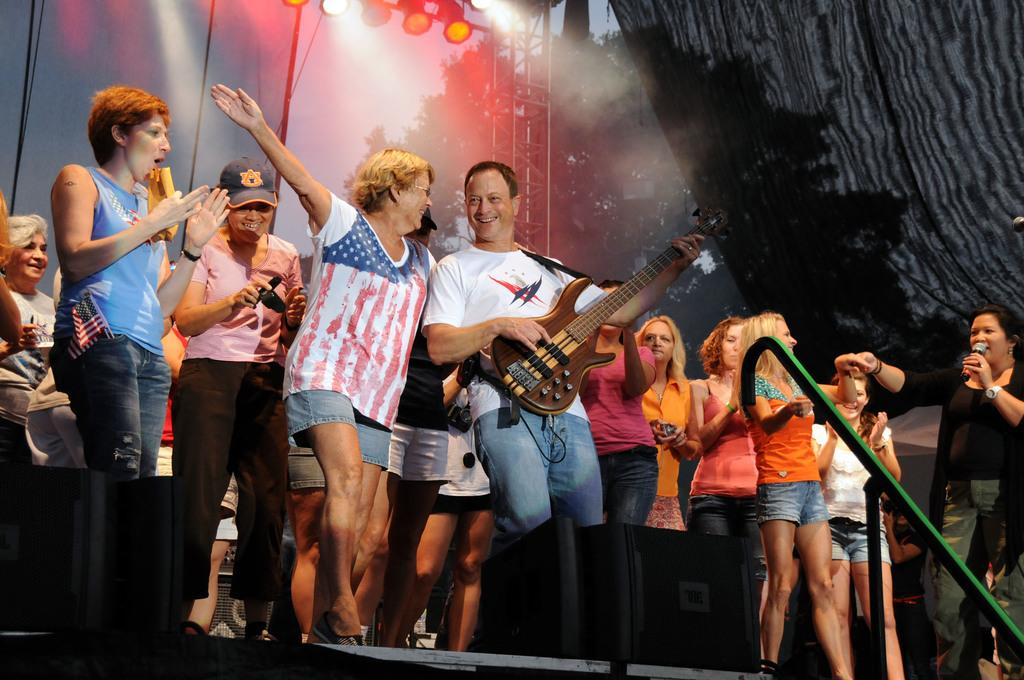How many people are visible in the image? There are many people standing in the image. What is one person holding in the image? A person is holding a guitar in the image. What is the person holding the guitar wearing? The person holding the guitar is wearing a white shirt. What is the lady wearing in the image? The lady is wearing a cap and a pink t-shirt. What can be seen in the background of the image? There is a curtain and lights visible in the background of the image. What type of oatmeal is being served to the dinosaurs in the image? There are no dinosaurs or oatmeal present in the image. What hobbies do the people in the image have, based on their clothing and accessories? The provided facts do not give enough information to determine the hobbies of the people in the image. 